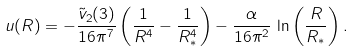Convert formula to latex. <formula><loc_0><loc_0><loc_500><loc_500>u ( R ) = - \frac { \tilde { v } _ { 2 } ( 3 ) } { 1 6 \pi ^ { 7 } } \left ( \frac { 1 } { R ^ { 4 } } - \frac { 1 } { R _ { * } ^ { 4 } } \right ) - \frac { \alpha } { 1 6 \pi ^ { 2 } } \, \ln \left ( \frac { R } { R _ { * } } \right ) .</formula> 